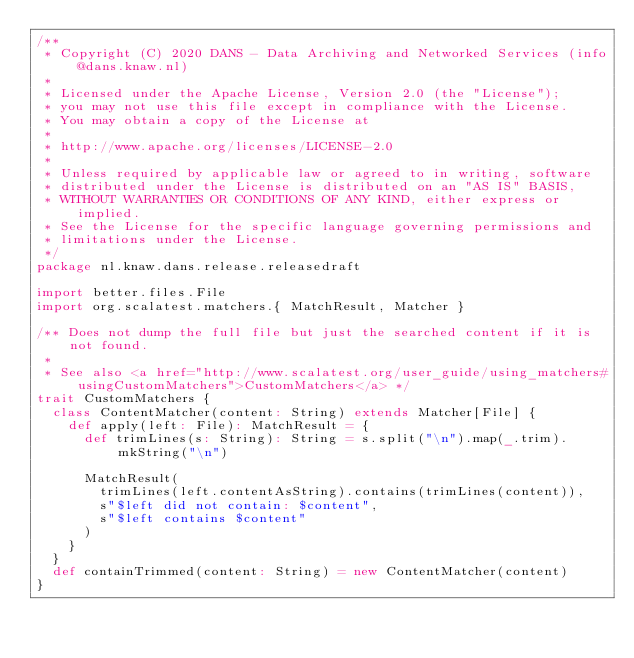Convert code to text. <code><loc_0><loc_0><loc_500><loc_500><_Scala_>/**
 * Copyright (C) 2020 DANS - Data Archiving and Networked Services (info@dans.knaw.nl)
 *
 * Licensed under the Apache License, Version 2.0 (the "License");
 * you may not use this file except in compliance with the License.
 * You may obtain a copy of the License at
 *
 * http://www.apache.org/licenses/LICENSE-2.0
 *
 * Unless required by applicable law or agreed to in writing, software
 * distributed under the License is distributed on an "AS IS" BASIS,
 * WITHOUT WARRANTIES OR CONDITIONS OF ANY KIND, either express or implied.
 * See the License for the specific language governing permissions and
 * limitations under the License.
 */
package nl.knaw.dans.release.releasedraft

import better.files.File
import org.scalatest.matchers.{ MatchResult, Matcher }

/** Does not dump the full file but just the searched content if it is not found.
 *
 * See also <a href="http://www.scalatest.org/user_guide/using_matchers#usingCustomMatchers">CustomMatchers</a> */
trait CustomMatchers {
  class ContentMatcher(content: String) extends Matcher[File] {
    def apply(left: File): MatchResult = {
      def trimLines(s: String): String = s.split("\n").map(_.trim).mkString("\n")

      MatchResult(
        trimLines(left.contentAsString).contains(trimLines(content)),
        s"$left did not contain: $content",
        s"$left contains $content"
      )
    }
  }
  def containTrimmed(content: String) = new ContentMatcher(content)
}
</code> 